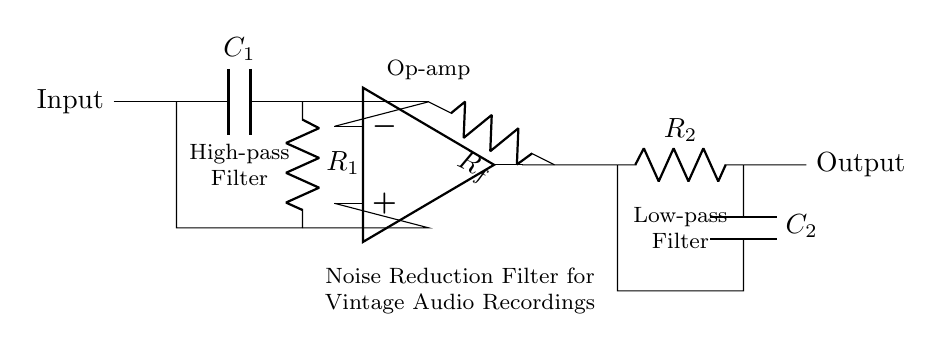What type of filter is shown in the circuit? The circuit diagram features both high-pass and low-pass filters, which are components designed to attenuate certain frequencies. The presence of capacitors and resistors indicates a filtering function; therefore, the overall type can be classified as a noise reduction filter that operates in both high and low frequencies.
Answer: Noise reduction filter How many resistors are in the circuit? The circuit contains three resistors: one in the high-pass filter (R1), one in the feedback loop (Rf), and one in the low-pass filter (R2). By counting the marked resistor components in the diagram, we find a total of three.
Answer: Three What is the purpose of the operational amplifier in this circuit? The operational amplifier acts as a signal processor that adjusts the gain and contributes to the filtering effect of the circuit. Its positioning in the feedback loop allows it to amplify the filtered signal while maintaining the overall circuit stability, making it critical for noise reduction.
Answer: Amplification Which component connects the output to the feedback? The connection from the output of the operational amplifier to the feedback loop is facilitated by the resistor labeled Rf. This resistor directly influences the feedback mechanism, helping to regulate the output signal to achieve the desired filtering effect.
Answer: Rf What role does capacitor C1 play in the circuit? Capacitor C1 serves as part of the high-pass filter section. It allows signals with frequencies above a certain cutoff frequency to pass while attenuating signals with lower frequencies. This selective passage is essential for reducing noise and improving audio quality in vintage recordings.
Answer: High-pass filtering 